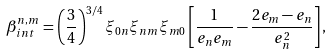<formula> <loc_0><loc_0><loc_500><loc_500>\beta _ { i n t } ^ { n , m } = \left ( \frac { 3 } { 4 } \right ) ^ { 3 / 4 } \xi _ { 0 n } \xi _ { n m } \xi _ { m 0 } \left [ \frac { 1 } { e _ { n } e _ { m } } - \frac { 2 e _ { m } - e _ { n } } { e _ { n } ^ { 2 } } \right ] ,</formula> 